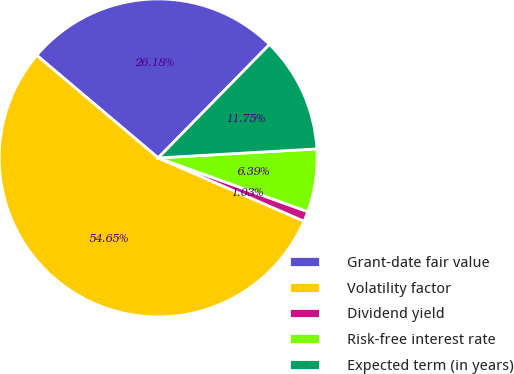Convert chart. <chart><loc_0><loc_0><loc_500><loc_500><pie_chart><fcel>Grant-date fair value<fcel>Volatility factor<fcel>Dividend yield<fcel>Risk-free interest rate<fcel>Expected term (in years)<nl><fcel>26.18%<fcel>54.65%<fcel>1.03%<fcel>6.39%<fcel>11.75%<nl></chart> 